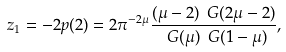<formula> <loc_0><loc_0><loc_500><loc_500>z _ { 1 } = - 2 p ( 2 ) = 2 \pi ^ { - 2 \mu } \frac { ( \mu - 2 ) \ G ( 2 \mu - 2 ) } { \ G ( \mu ) \ G ( 1 - \mu ) } ,</formula> 